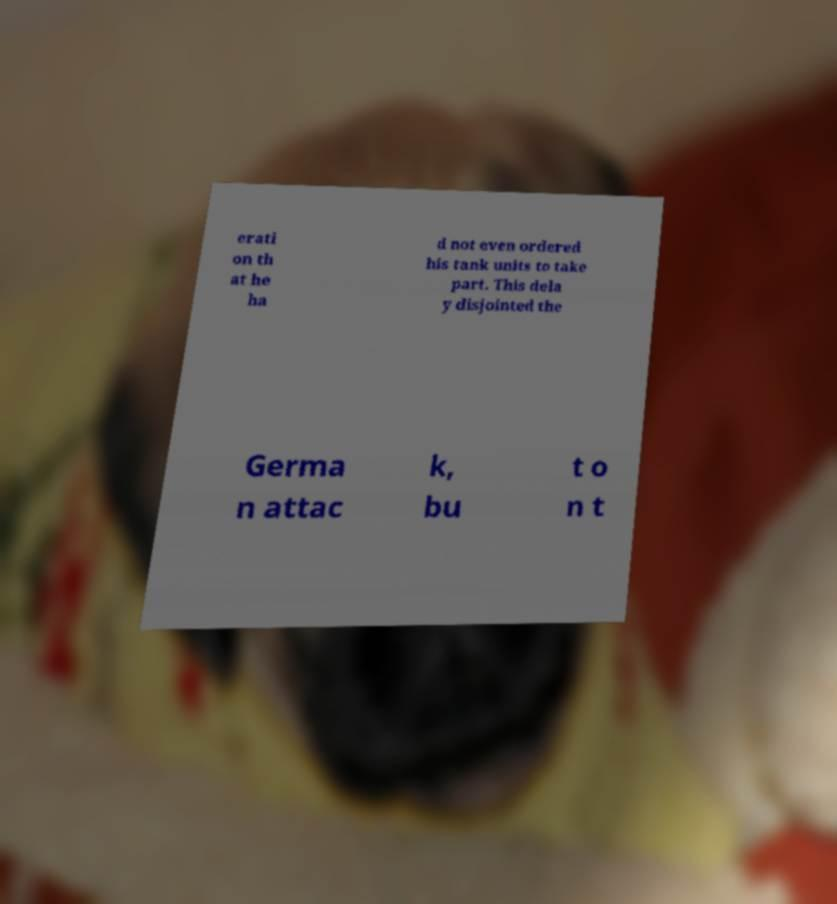There's text embedded in this image that I need extracted. Can you transcribe it verbatim? erati on th at he ha d not even ordered his tank units to take part. This dela y disjointed the Germa n attac k, bu t o n t 